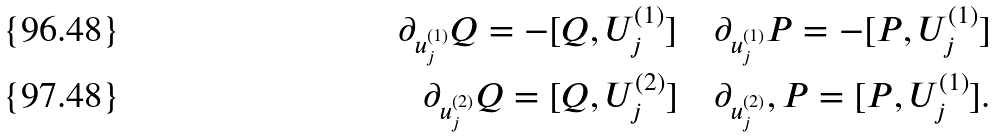<formula> <loc_0><loc_0><loc_500><loc_500>\partial _ { u ^ { ( 1 ) } _ { j } } Q = - [ Q , U ^ { ( 1 ) } _ { j } ] \quad \partial _ { u ^ { ( 1 ) } _ { j } } P = - [ P , U ^ { ( 1 ) } _ { j } ] \\ \partial _ { u ^ { ( 2 ) } _ { j } } Q = [ Q , U ^ { ( 2 ) } _ { j } ] \quad \partial _ { u ^ { ( 2 ) } _ { j } } , P = [ P , U ^ { ( 1 ) } _ { j } ] .</formula> 